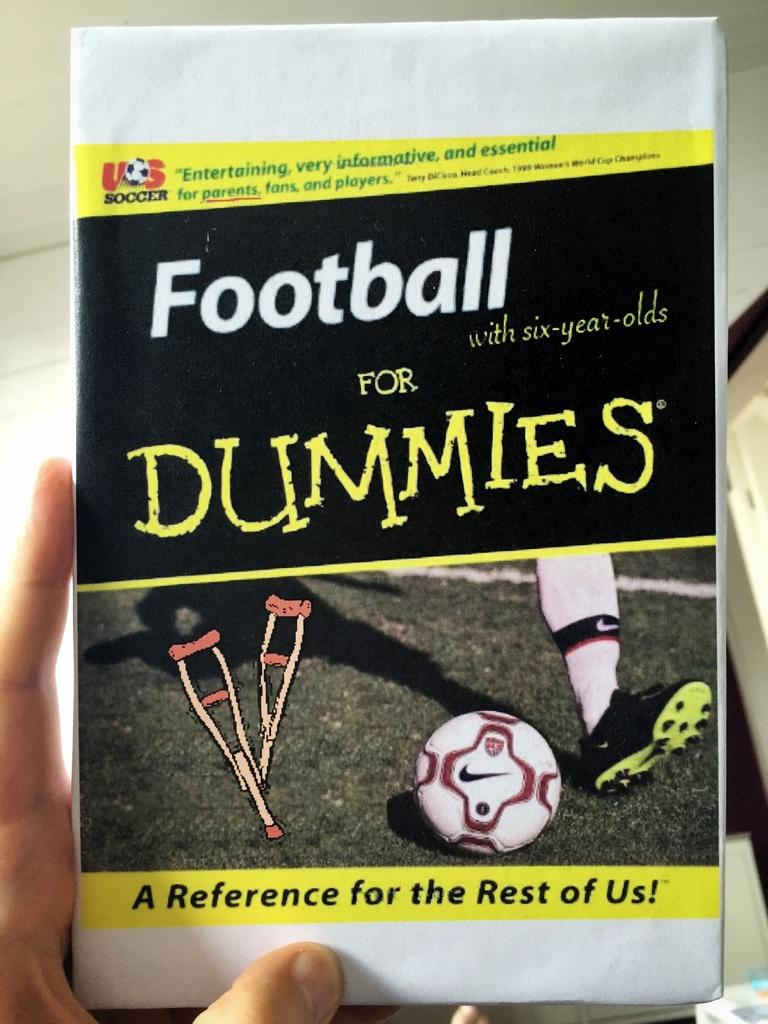<image>
Summarize the visual content of the image. A close up of a hand holding a book with the name "Football for Dummies" 